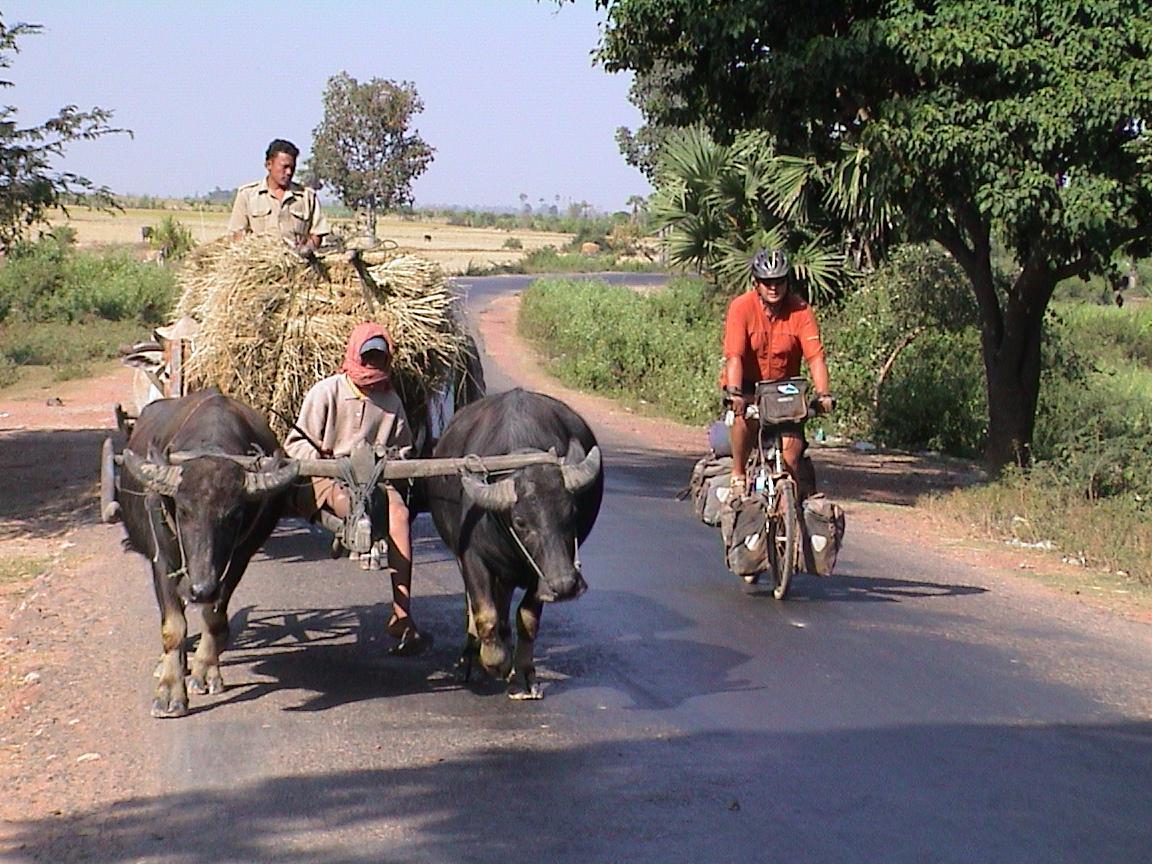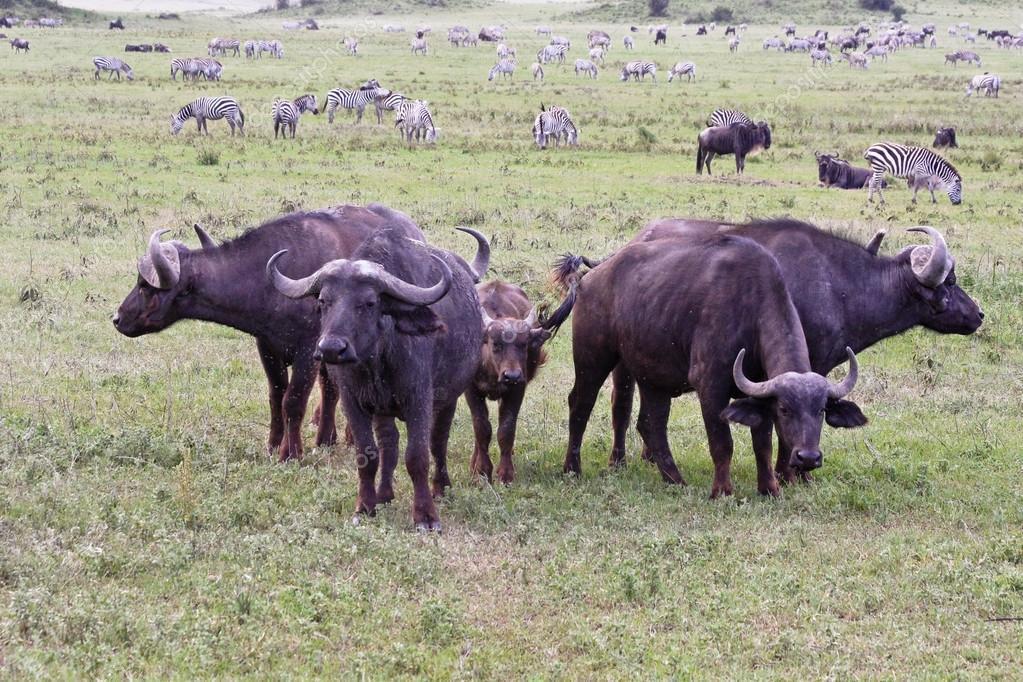The first image is the image on the left, the second image is the image on the right. Given the left and right images, does the statement "At least one person is behind a hitched team of two water buffalo in one image." hold true? Answer yes or no. Yes. 